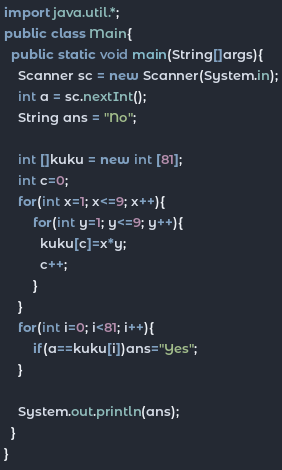Convert code to text. <code><loc_0><loc_0><loc_500><loc_500><_Java_>import java.util.*;
public class Main{
  public static void main(String[]args){
  	Scanner sc = new Scanner(System.in);
    int a = sc.nextInt();
    String ans = "No";
    
    int []kuku = new int [81];
    int c=0;
    for(int x=1; x<=9; x++){
    	for(int y=1; y<=9; y++){
          kuku[c]=x*y;
          c++;
        }
    }
    for(int i=0; i<81; i++){
    	if(a==kuku[i])ans="Yes";
    }
    
    System.out.println(ans);
  }
}</code> 